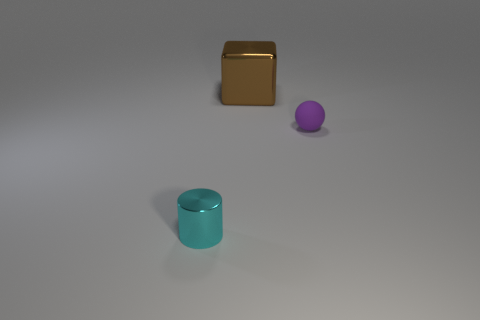Add 1 metallic cylinders. How many objects exist? 4 Subtract all cubes. How many objects are left? 2 Subtract all tiny metallic objects. Subtract all purple spheres. How many objects are left? 1 Add 3 large shiny things. How many large shiny things are left? 4 Add 1 small purple rubber spheres. How many small purple rubber spheres exist? 2 Subtract 0 purple cubes. How many objects are left? 3 